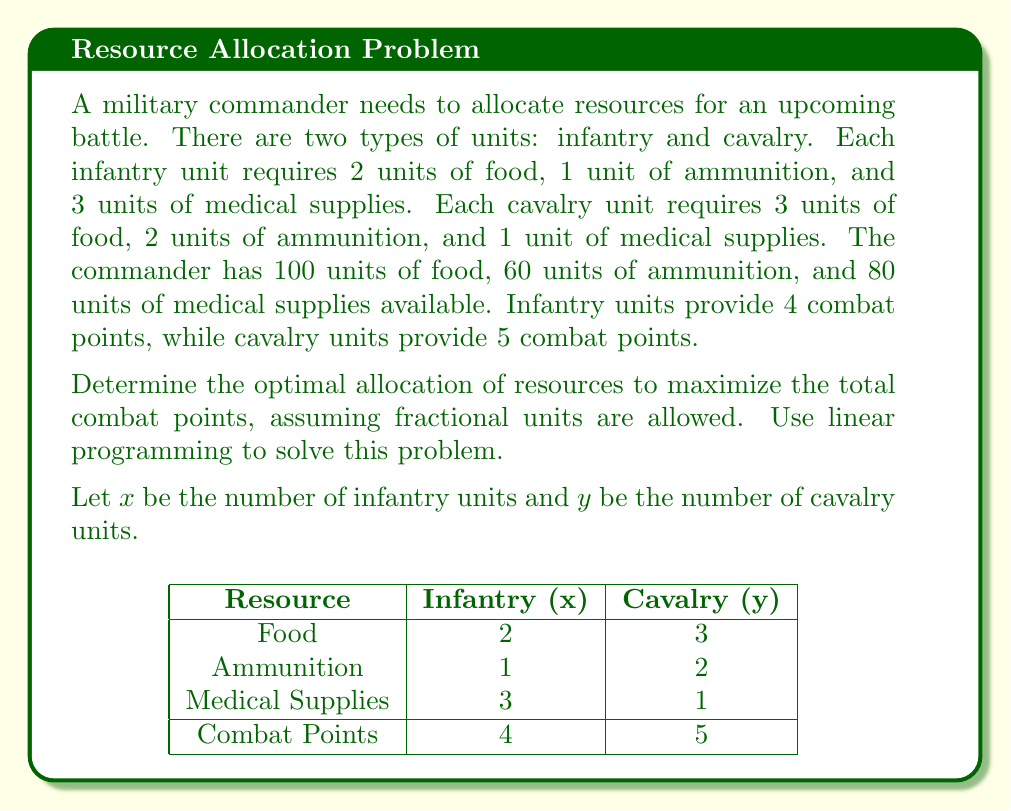Teach me how to tackle this problem. To solve this linear programming problem, we'll follow these steps:

1) Define the objective function:
   Maximize $Z = 4x + 5y$ (total combat points)

2) Set up the constraints:
   Food: $2x + 3y \leq 100$
   Ammunition: $x + 2y \leq 60$
   Medical supplies: $3x + y \leq 80$
   Non-negativity: $x \geq 0, y \geq 0$

3) Graph the constraints:
   [asy]
   import graph;
   size(200);
   xaxis("x", 0, 50);
   yaxis("y", 0, 50);
   draw((0,33.33)--(50,0), blue);
   draw((0,30)--(60,0), red);
   draw((0,80)--(26.67,0), green);
   label("Food", (25,15), blue);
   label("Ammo", (30,10), red);
   label("Medical", (13,40), green);
   [/asy]

4) Identify the feasible region (shaded area in the graph).

5) Find the corner points of the feasible region:
   (0,0), (0,30), (20,20), (26.67,0)

6) Evaluate the objective function at each corner point:
   At (0,0): $Z = 4(0) + 5(0) = 0$
   At (0,30): $Z = 4(0) + 5(30) = 150$
   At (20,20): $Z = 4(20) + 5(20) = 180$
   At (26.67,0): $Z = 4(26.67) + 5(0) = 106.68$

7) The maximum value occurs at (20,20), so this is the optimal solution.

Therefore, the optimal allocation is 20 infantry units and 20 cavalry units, resulting in a maximum of 180 combat points.
Answer: 20 infantry units, 20 cavalry units; 180 combat points 